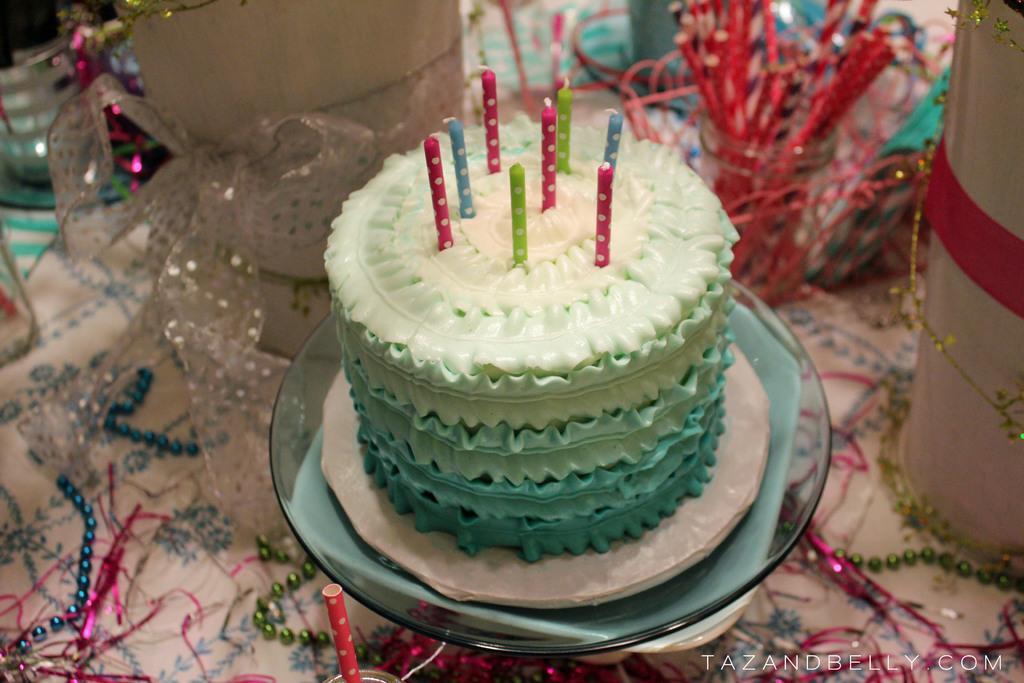Please provide a concise description of this image. In this image we can see the cake on the cake stand which is in the middle of the picture and on the top of the cake we can see some candles. We can see some decorative items on the surface. 